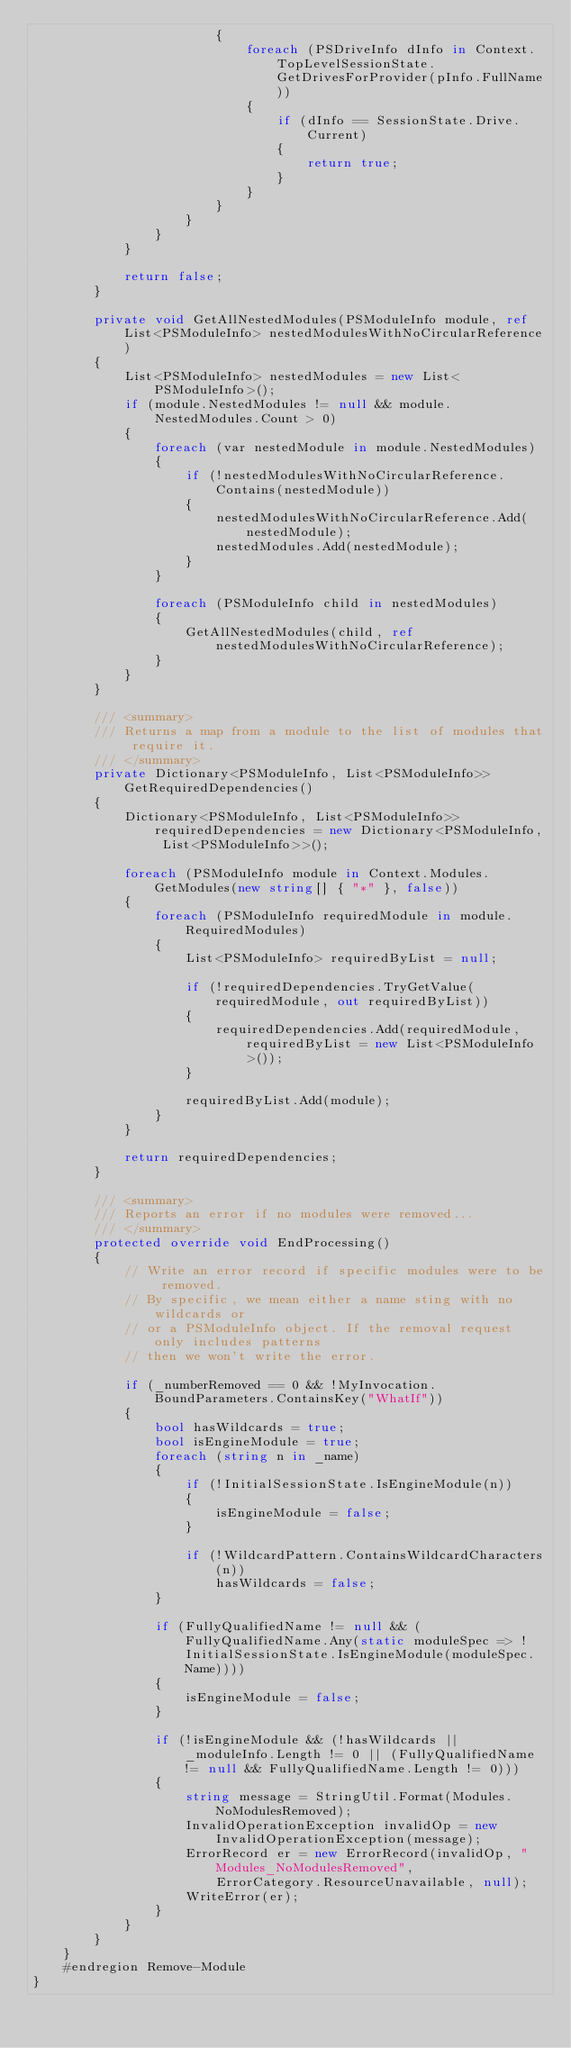<code> <loc_0><loc_0><loc_500><loc_500><_C#_>                        {
                            foreach (PSDriveInfo dInfo in Context.TopLevelSessionState.GetDrivesForProvider(pInfo.FullName))
                            {
                                if (dInfo == SessionState.Drive.Current)
                                {
                                    return true;
                                }
                            }
                        }
                    }
                }
            }

            return false;
        }

        private void GetAllNestedModules(PSModuleInfo module, ref List<PSModuleInfo> nestedModulesWithNoCircularReference)
        {
            List<PSModuleInfo> nestedModules = new List<PSModuleInfo>();
            if (module.NestedModules != null && module.NestedModules.Count > 0)
            {
                foreach (var nestedModule in module.NestedModules)
                {
                    if (!nestedModulesWithNoCircularReference.Contains(nestedModule))
                    {
                        nestedModulesWithNoCircularReference.Add(nestedModule);
                        nestedModules.Add(nestedModule);
                    }
                }

                foreach (PSModuleInfo child in nestedModules)
                {
                    GetAllNestedModules(child, ref nestedModulesWithNoCircularReference);
                }
            }
        }

        /// <summary>
        /// Returns a map from a module to the list of modules that require it.
        /// </summary>
        private Dictionary<PSModuleInfo, List<PSModuleInfo>> GetRequiredDependencies()
        {
            Dictionary<PSModuleInfo, List<PSModuleInfo>> requiredDependencies = new Dictionary<PSModuleInfo, List<PSModuleInfo>>();

            foreach (PSModuleInfo module in Context.Modules.GetModules(new string[] { "*" }, false))
            {
                foreach (PSModuleInfo requiredModule in module.RequiredModules)
                {
                    List<PSModuleInfo> requiredByList = null;

                    if (!requiredDependencies.TryGetValue(requiredModule, out requiredByList))
                    {
                        requiredDependencies.Add(requiredModule, requiredByList = new List<PSModuleInfo>());
                    }

                    requiredByList.Add(module);
                }
            }

            return requiredDependencies;
        }

        /// <summary>
        /// Reports an error if no modules were removed...
        /// </summary>
        protected override void EndProcessing()
        {
            // Write an error record if specific modules were to be removed.
            // By specific, we mean either a name sting with no wildcards or
            // or a PSModuleInfo object. If the removal request only includes patterns
            // then we won't write the error.

            if (_numberRemoved == 0 && !MyInvocation.BoundParameters.ContainsKey("WhatIf"))
            {
                bool hasWildcards = true;
                bool isEngineModule = true;
                foreach (string n in _name)
                {
                    if (!InitialSessionState.IsEngineModule(n))
                    {
                        isEngineModule = false;
                    }

                    if (!WildcardPattern.ContainsWildcardCharacters(n))
                        hasWildcards = false;
                }

                if (FullyQualifiedName != null && (FullyQualifiedName.Any(static moduleSpec => !InitialSessionState.IsEngineModule(moduleSpec.Name))))
                {
                    isEngineModule = false;
                }

                if (!isEngineModule && (!hasWildcards || _moduleInfo.Length != 0 || (FullyQualifiedName != null && FullyQualifiedName.Length != 0)))
                {
                    string message = StringUtil.Format(Modules.NoModulesRemoved);
                    InvalidOperationException invalidOp = new InvalidOperationException(message);
                    ErrorRecord er = new ErrorRecord(invalidOp, "Modules_NoModulesRemoved",
                        ErrorCategory.ResourceUnavailable, null);
                    WriteError(er);
                }
            }
        }
    }
    #endregion Remove-Module
}
</code> 